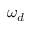<formula> <loc_0><loc_0><loc_500><loc_500>\omega _ { d }</formula> 